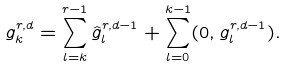<formula> <loc_0><loc_0><loc_500><loc_500>g ^ { r , d } _ { k } = \sum _ { l = k } ^ { r - 1 } \hat { g } ^ { r , d - 1 } _ { l } + \sum _ { l = 0 } ^ { k - 1 } ( 0 , g ^ { r , d - 1 } _ { l } ) .</formula> 